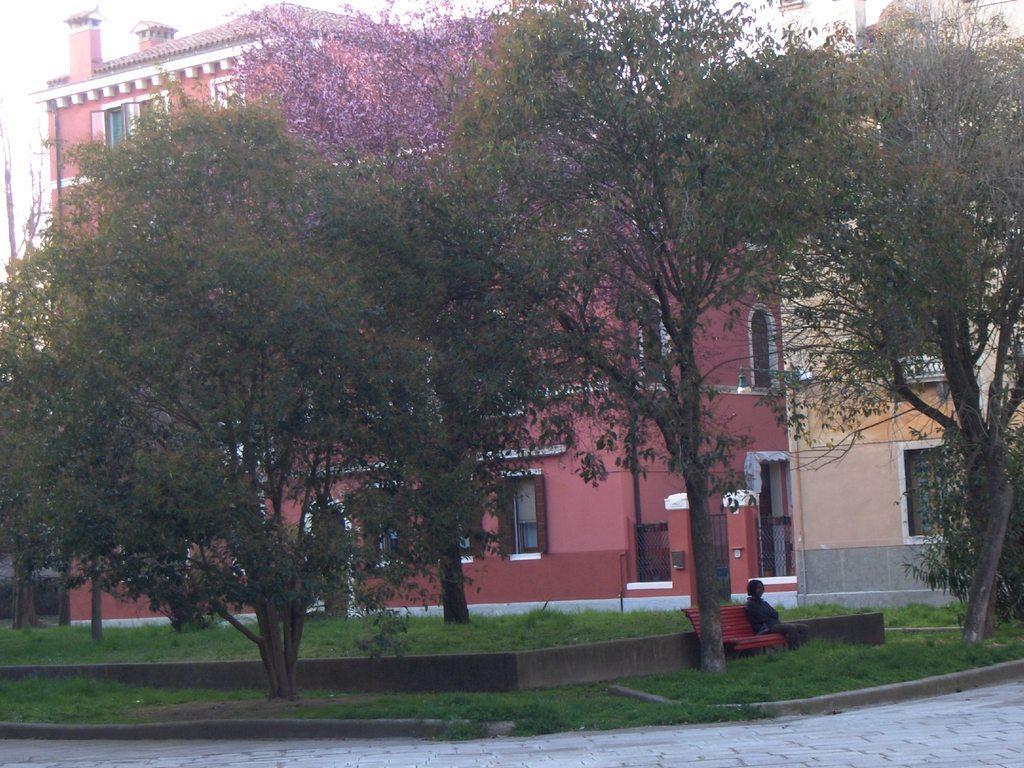How would you summarize this image in a sentence or two? In this picture I see the path in front and in the middle of this picture I see the trees and the grass and I see a bench on which there is a person sitting. In the background I see the buildings. 